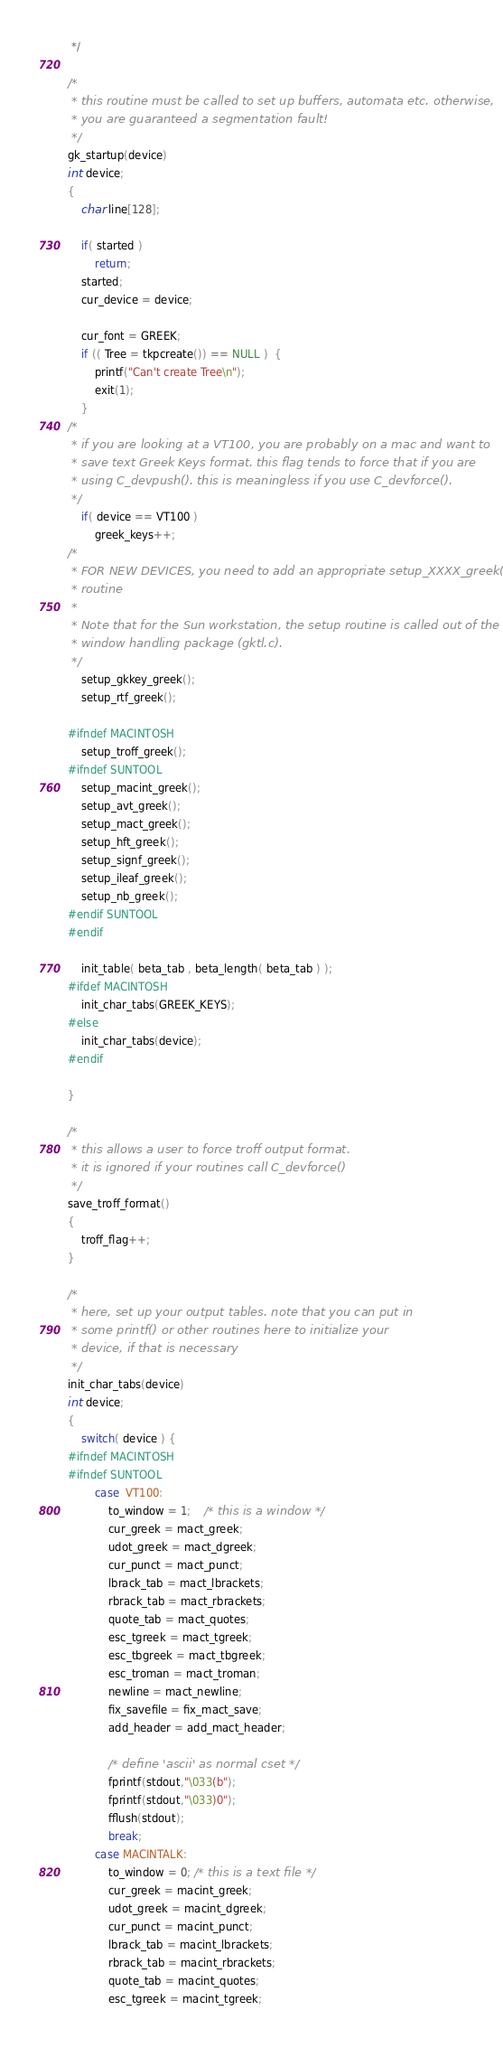Convert code to text. <code><loc_0><loc_0><loc_500><loc_500><_C_> */

/*
 * this routine must be called to set up buffers, automata etc. otherwise,
 * you are guaranteed a segmentation fault!
 */
gk_startup(device)
int device;
{
	char line[128];
	
	if( started )
		return;
	started;
	cur_device = device;

	cur_font = GREEK;
	if (( Tree = tkpcreate()) == NULL )  {
	    printf("Can't create Tree\n");
	    exit(1);
	}
/* 
 * if you are looking at a VT100, you are probably on a mac and want to
 * save text Greek Keys format. this flag tends to force that if you are
 * using C_devpush(). this is meaningless if you use C_devforce().
 */
	if( device == VT100 )
		greek_keys++;
/*
 * FOR NEW DEVICES, you need to add an appropriate setup_XXXX_greek()
 * routine
 *
 * Note that for the Sun workstation, the setup routine is called out of the
 * window handling package (gktl.c).
 */
	setup_gkkey_greek();
	setup_rtf_greek();
	
#ifndef MACINTOSH
	setup_troff_greek();
#ifndef SUNTOOL
	setup_macint_greek();
	setup_avt_greek();
	setup_mact_greek();
	setup_hft_greek();
	setup_signf_greek();
 	setup_ileaf_greek();
 	setup_nb_greek();
#endif SUNTOOL
#endif

	init_table( beta_tab , beta_length( beta_tab ) );
#ifdef MACINTOSH
	init_char_tabs(GREEK_KEYS);
#else
	init_char_tabs(device);
#endif

}

/*
 * this allows a user to force troff output format.
 * it is ignored if your routines call C_devforce()
 */
save_troff_format()
{
	troff_flag++;
}

/*
 * here, set up your output tables. note that you can put in
 * some printf() or other routines here to initialize your
 * device, if that is necessary
 */
init_char_tabs(device)
int device;
{
	switch( device ) {
#ifndef MACINTOSH
#ifndef SUNTOOL
		case  VT100:
			to_window = 1;	/* this is a window */
			cur_greek = mact_greek;
			udot_greek = mact_dgreek;
			cur_punct = mact_punct;
			lbrack_tab = mact_lbrackets;
			rbrack_tab = mact_rbrackets;
			quote_tab = mact_quotes;
			esc_tgreek = mact_tgreek;
			esc_tbgreek = mact_tbgreek;
			esc_troman = mact_troman;
			newline = mact_newline;
			fix_savefile = fix_mact_save;
			add_header = add_mact_header;

			/* define 'ascii' as normal cset */
			fprintf(stdout,"\033(b");
			fprintf(stdout,"\033)0");
			fflush(stdout);
			break;	
		case MACINTALK:
			to_window = 0; /* this is a text file */
			cur_greek = macint_greek;
			udot_greek = macint_dgreek;
			cur_punct = macint_punct;
			lbrack_tab = macint_lbrackets;
			rbrack_tab = macint_rbrackets;
			quote_tab = macint_quotes;
			esc_tgreek = macint_tgreek;</code> 